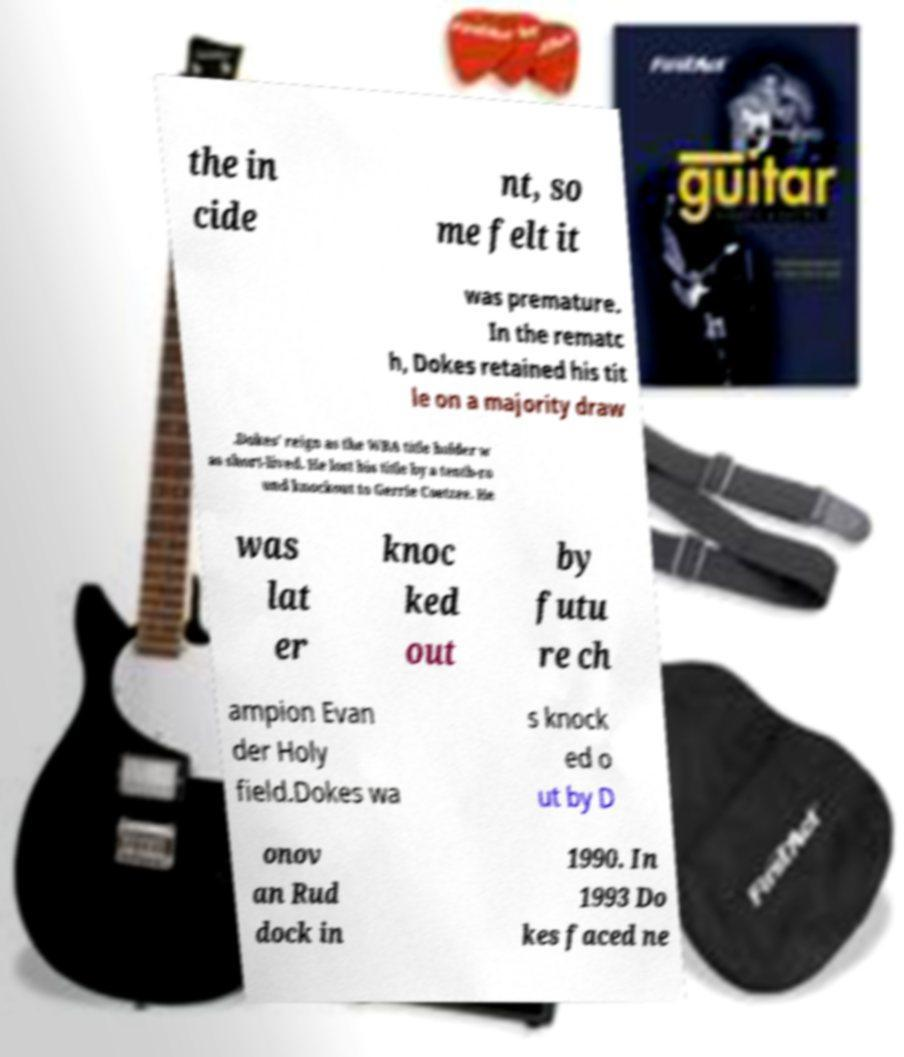Please read and relay the text visible in this image. What does it say? the in cide nt, so me felt it was premature. In the rematc h, Dokes retained his tit le on a majority draw .Dokes' reign as the WBA title holder w as short-lived. He lost his title by a tenth-ro und knockout to Gerrie Coetzee. He was lat er knoc ked out by futu re ch ampion Evan der Holy field.Dokes wa s knock ed o ut by D onov an Rud dock in 1990. In 1993 Do kes faced ne 